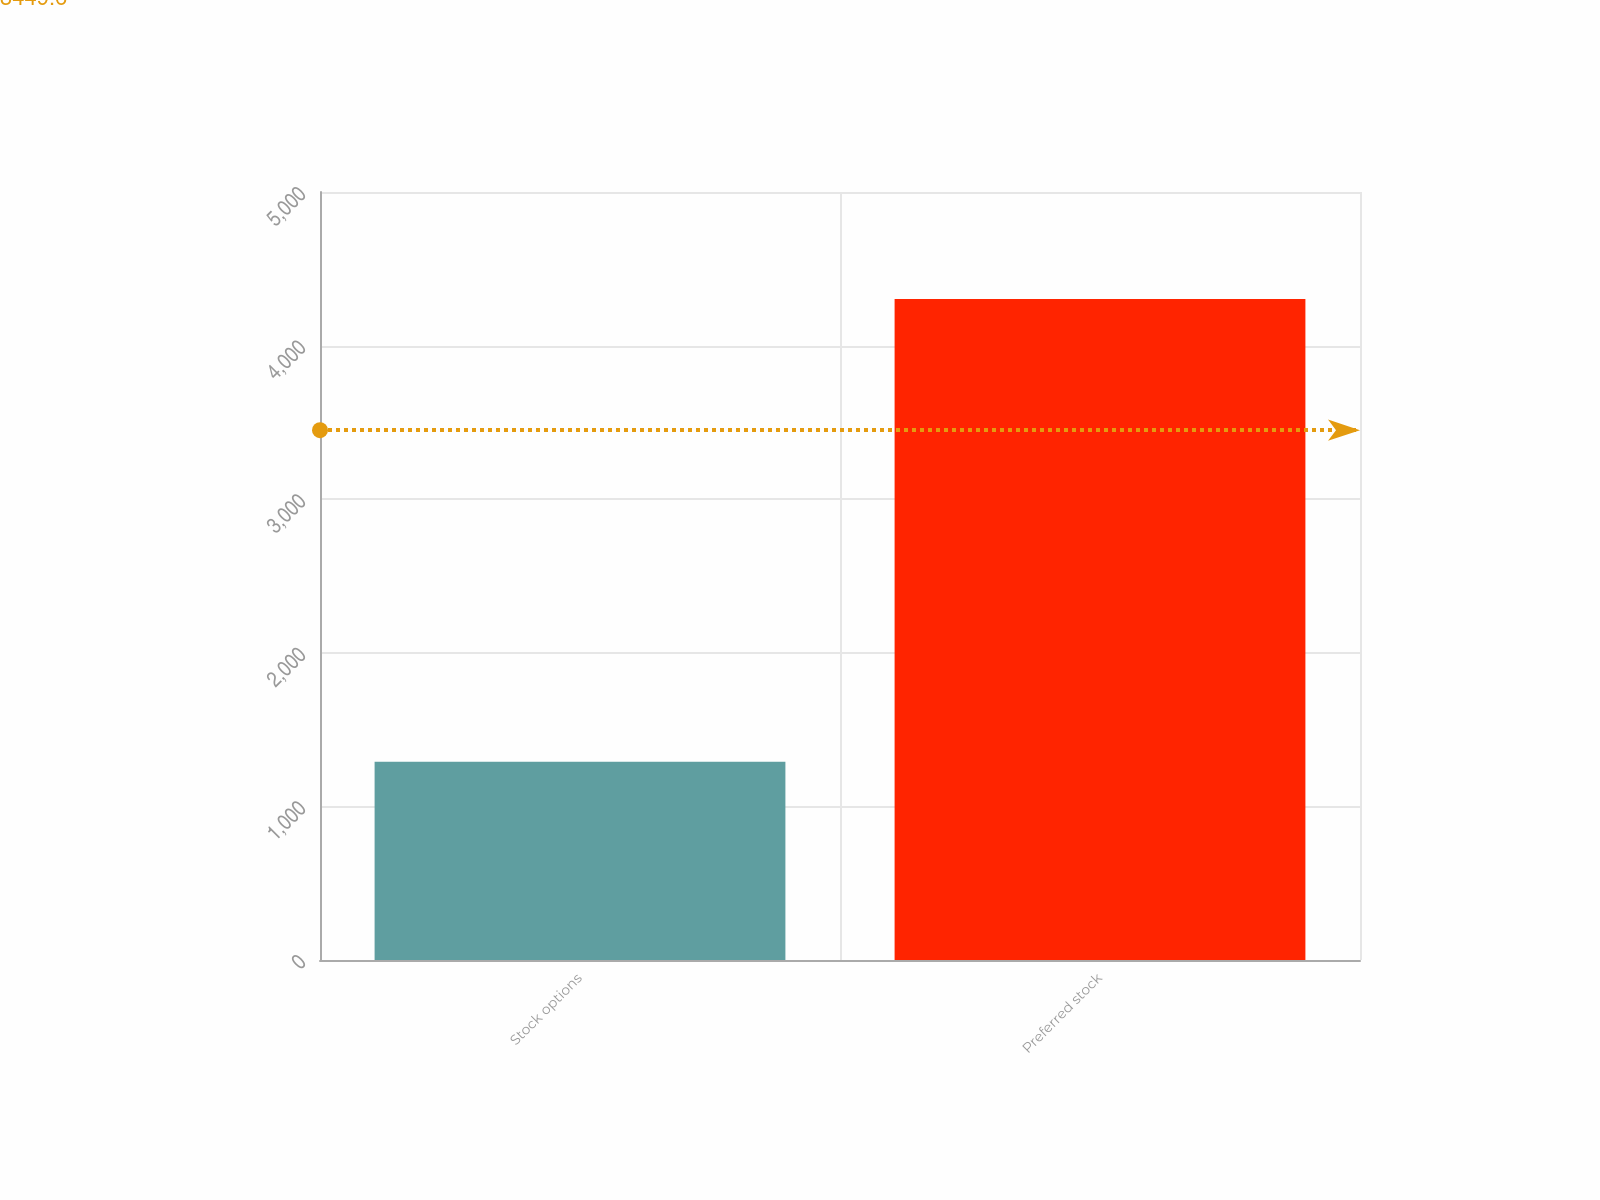<chart> <loc_0><loc_0><loc_500><loc_500><bar_chart><fcel>Stock options<fcel>Preferred stock<nl><fcel>1290<fcel>4303<nl></chart> 